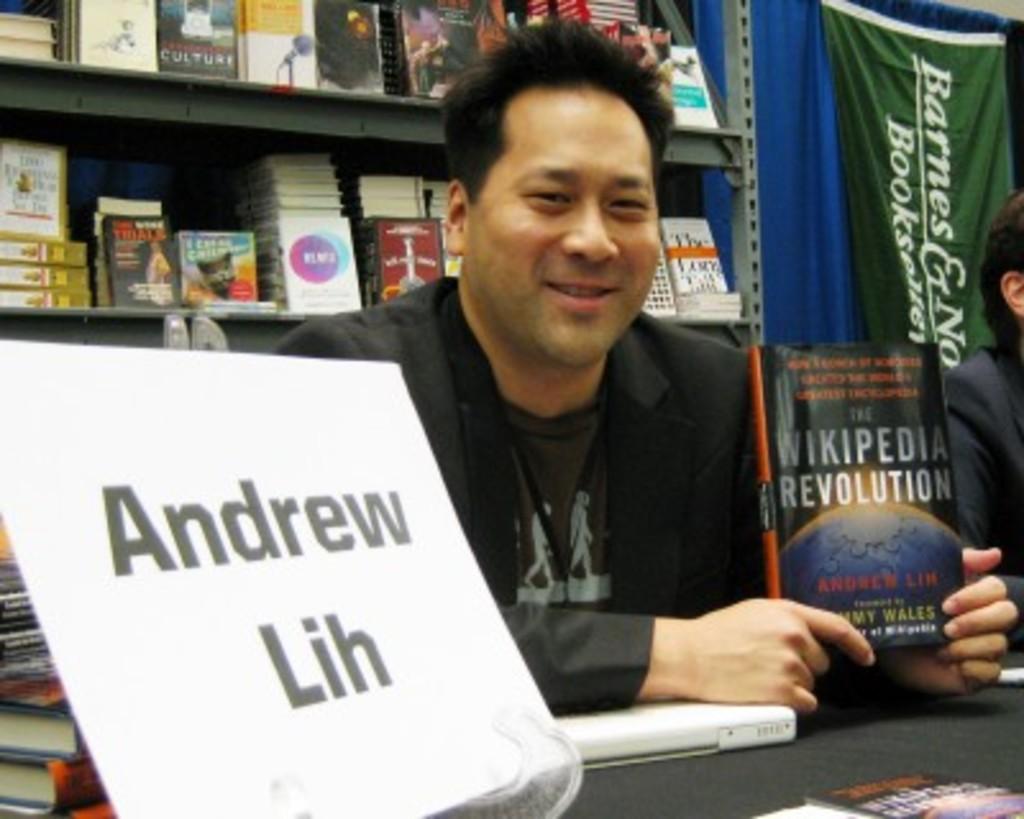Who is the author of the book?
Your answer should be compact. Andrew lih. 